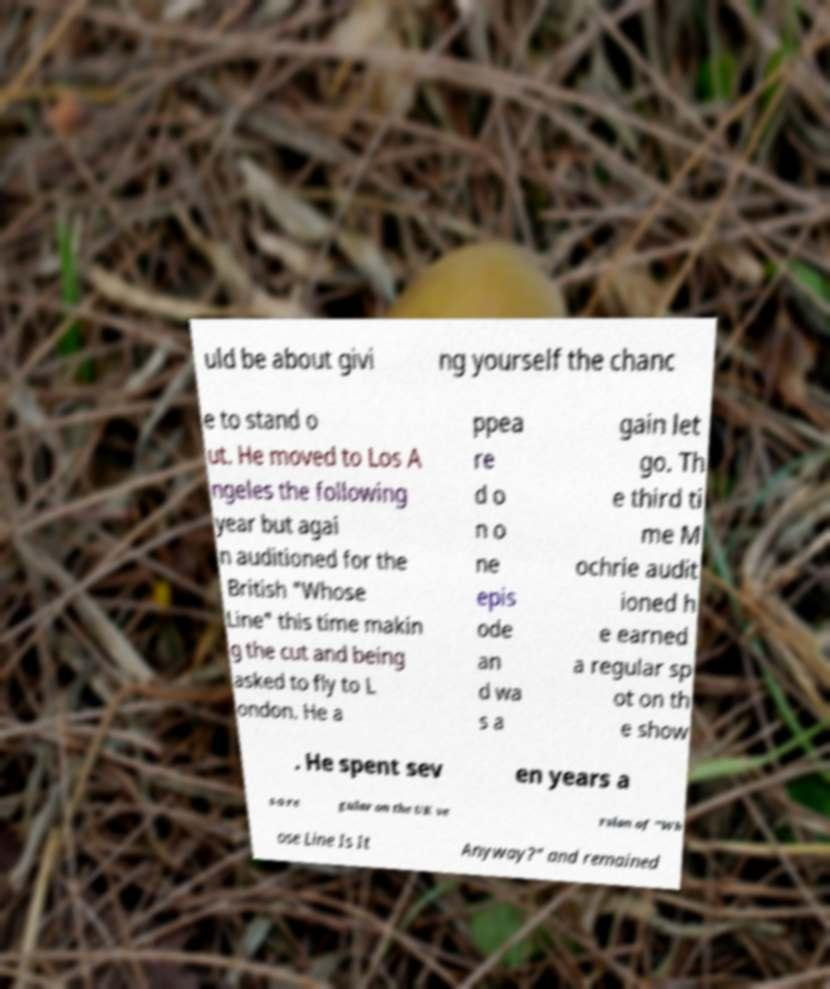Please read and relay the text visible in this image. What does it say? uld be about givi ng yourself the chanc e to stand o ut. He moved to Los A ngeles the following year but agai n auditioned for the British "Whose Line" this time makin g the cut and being asked to fly to L ondon. He a ppea re d o n o ne epis ode an d wa s a gain let go. Th e third ti me M ochrie audit ioned h e earned a regular sp ot on th e show . He spent sev en years a s a re gular on the UK ve rsion of "Wh ose Line Is It Anyway?" and remained 